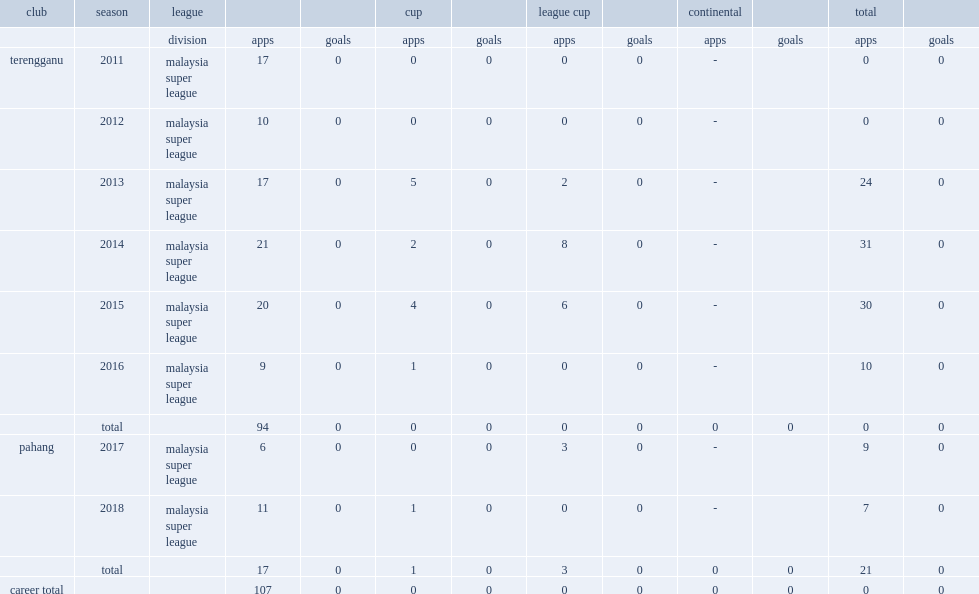Which club did zubir azmi play for in 2017? Pahang. 